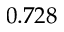Convert formula to latex. <formula><loc_0><loc_0><loc_500><loc_500>0 . 7 2 8</formula> 